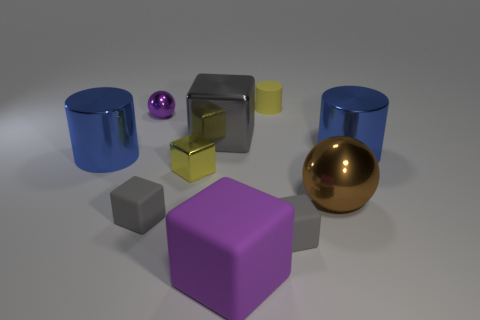Subtract all blue cylinders. How many gray blocks are left? 3 Subtract all brown cubes. Subtract all purple balls. How many cubes are left? 5 Subtract all spheres. How many objects are left? 8 Subtract all large brown shiny spheres. Subtract all large cylinders. How many objects are left? 7 Add 5 large purple rubber things. How many large purple rubber things are left? 6 Add 7 tiny matte objects. How many tiny matte objects exist? 10 Subtract 0 cyan cylinders. How many objects are left? 10 